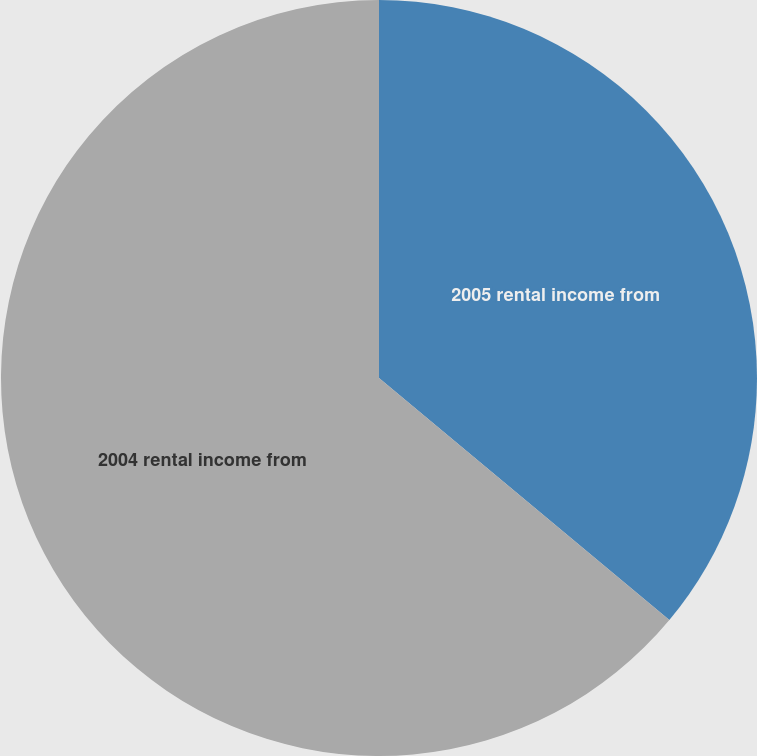Convert chart. <chart><loc_0><loc_0><loc_500><loc_500><pie_chart><fcel>2005 rental income from<fcel>2004 rental income from<nl><fcel>36.06%<fcel>63.94%<nl></chart> 